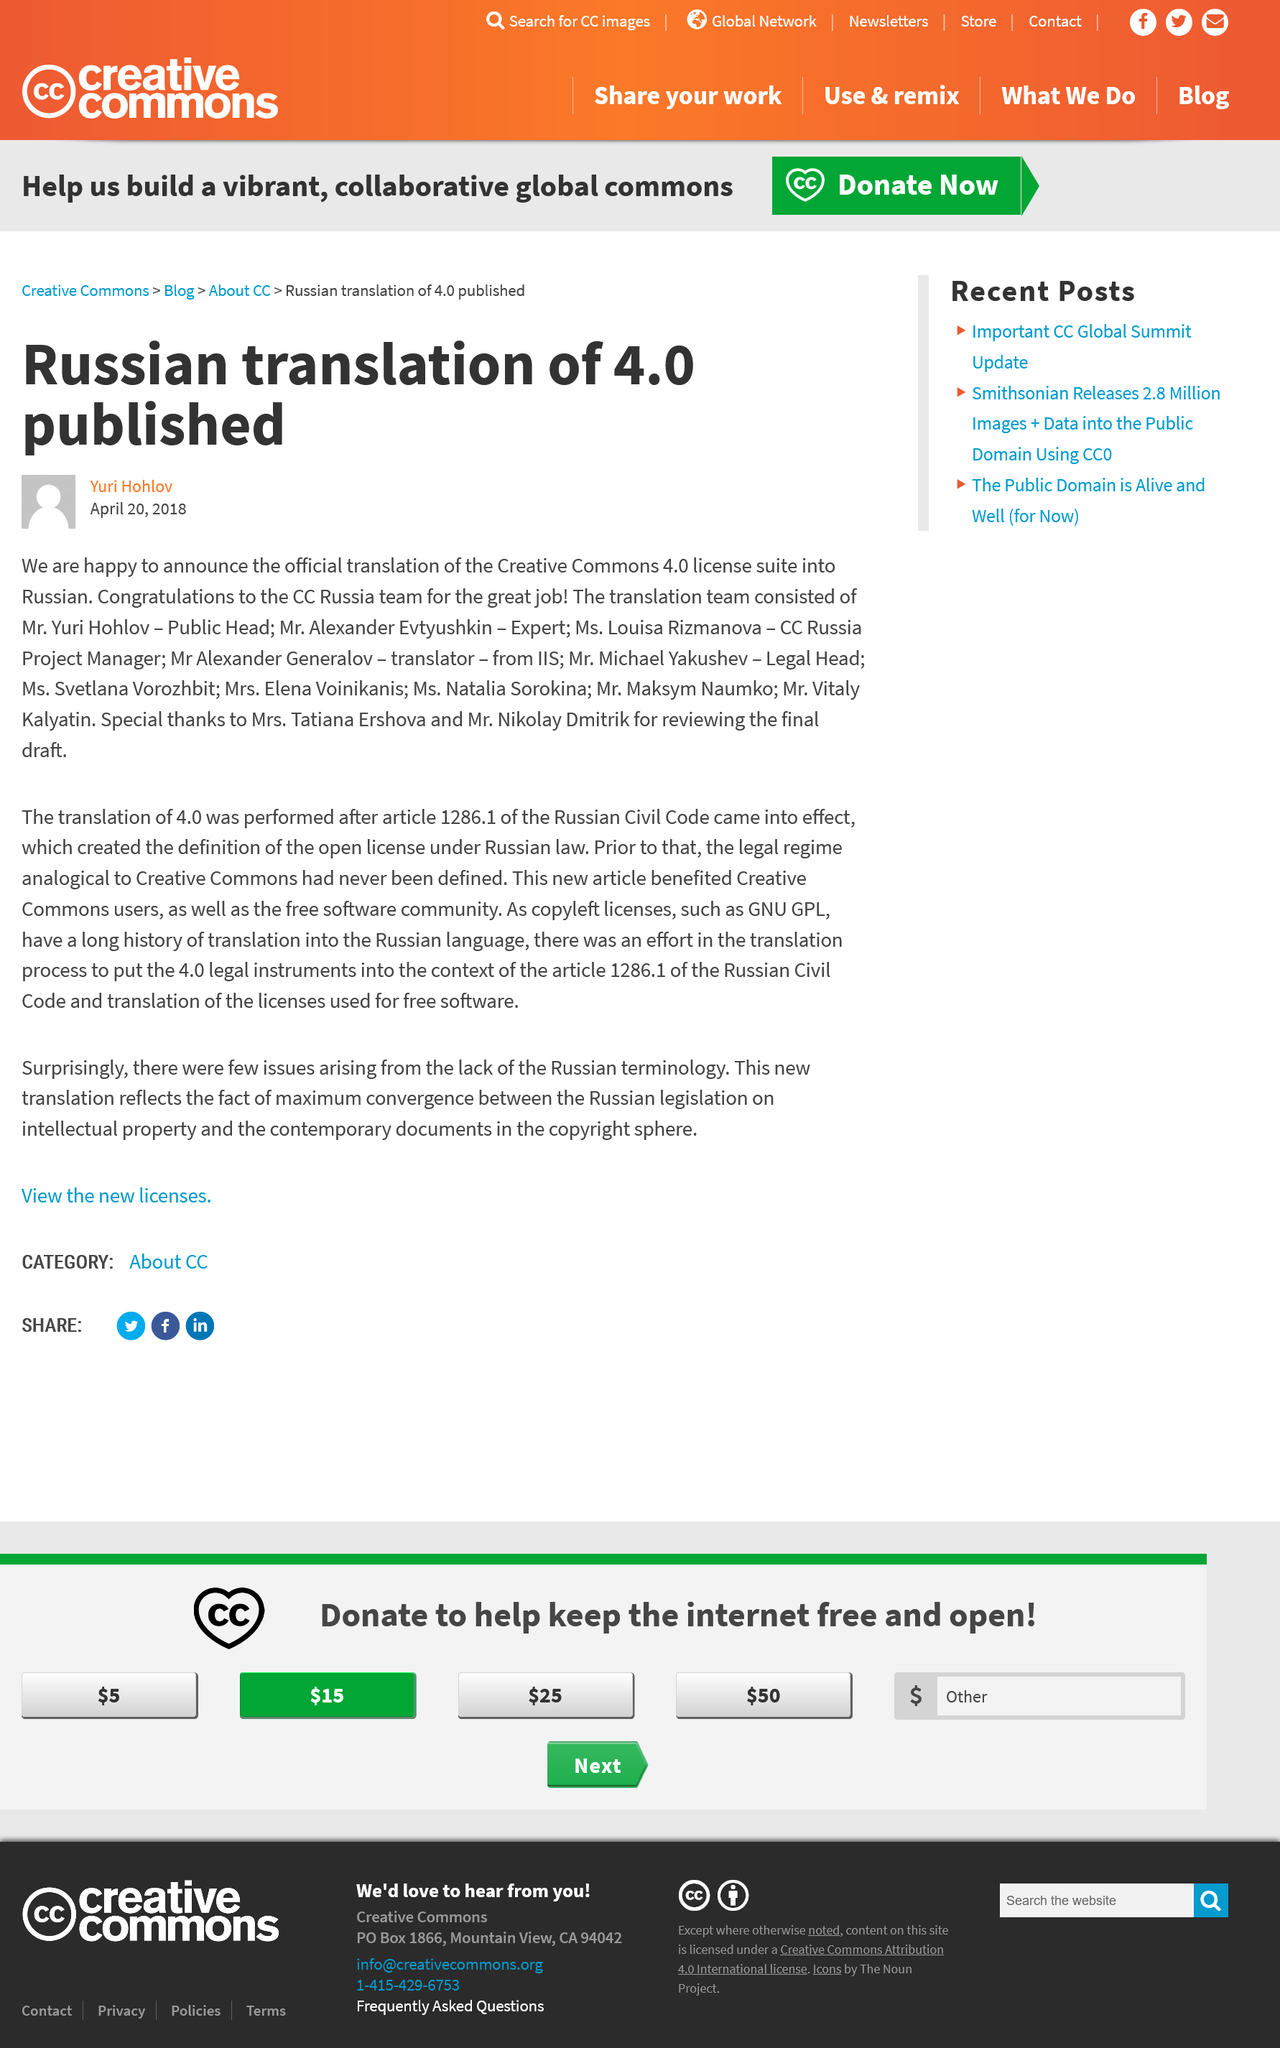Identify some key points in this picture. The author of this article is Yuri Hohlov. The article was written on April 20, 2018. The Creative Commons license version 4.0 has been translated into Russian. 